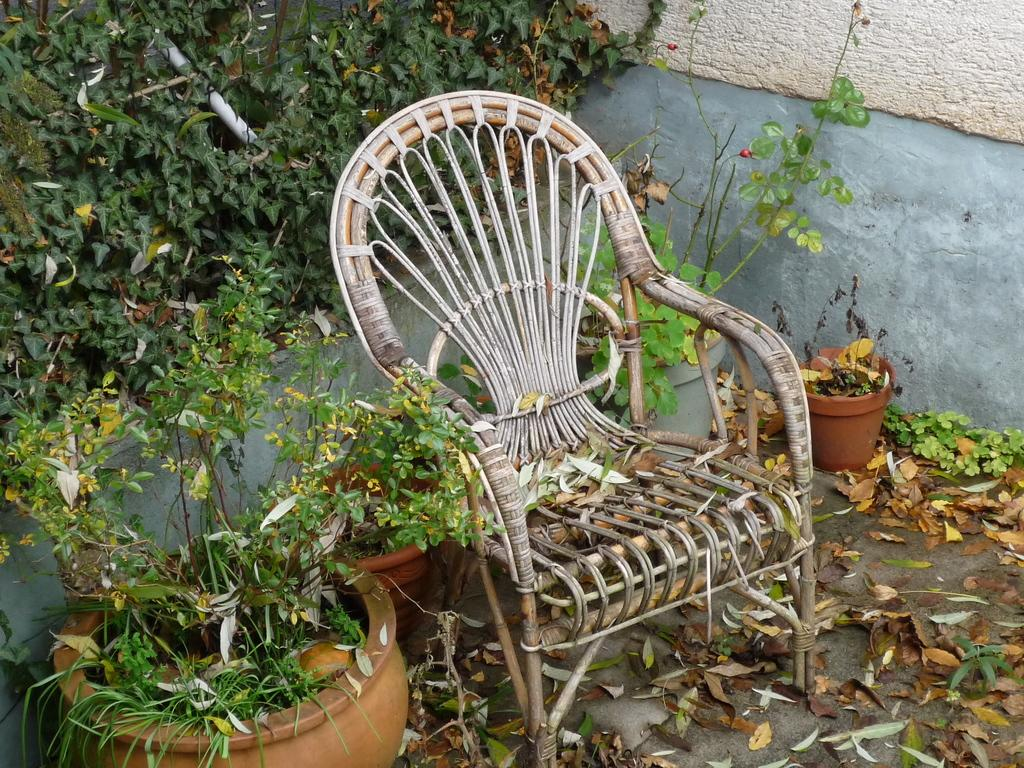What type of furniture is present in the image? There is a chair in the image. What type of decorative items can be seen in the image? There are flower pots in the image. What architectural feature is visible in the image? There is a wall in the image. What type of health advice can be seen written on the wall in the image? There is no health advice visible on the wall in the image. What type of insect can be seen crawling on the chair in the image? There is no insect present on the chair in the image. 